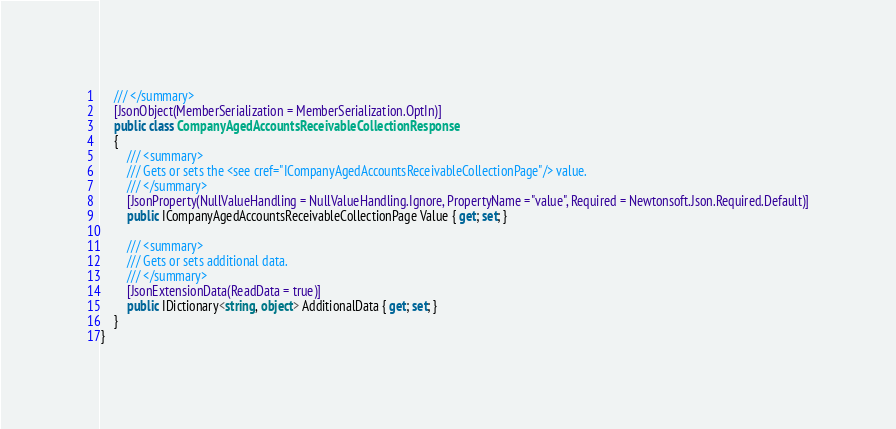<code> <loc_0><loc_0><loc_500><loc_500><_C#_>    /// </summary>
    [JsonObject(MemberSerialization = MemberSerialization.OptIn)]
    public class CompanyAgedAccountsReceivableCollectionResponse
    {
        /// <summary>
        /// Gets or sets the <see cref="ICompanyAgedAccountsReceivableCollectionPage"/> value.
        /// </summary>
		[JsonProperty(NullValueHandling = NullValueHandling.Ignore, PropertyName ="value", Required = Newtonsoft.Json.Required.Default)]
        public ICompanyAgedAccountsReceivableCollectionPage Value { get; set; }

        /// <summary>
        /// Gets or sets additional data.
        /// </summary>
        [JsonExtensionData(ReadData = true)]
        public IDictionary<string, object> AdditionalData { get; set; }
    }
}
</code> 